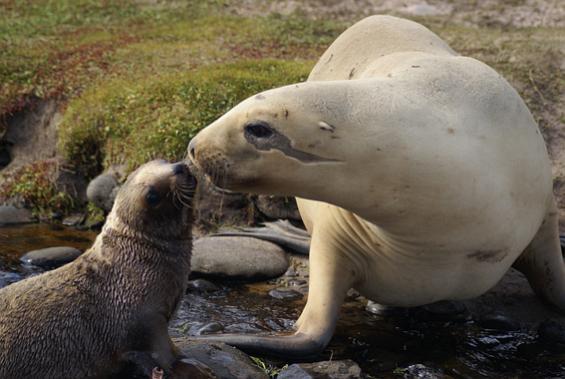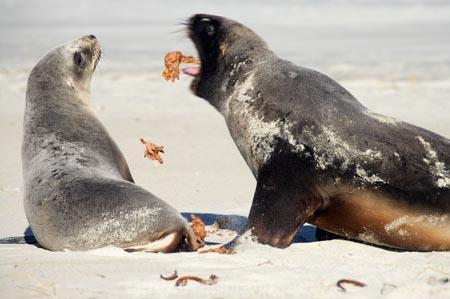The first image is the image on the left, the second image is the image on the right. Considering the images on both sides, is "There are four sea lions in the image pair." valid? Answer yes or no. Yes. The first image is the image on the left, the second image is the image on the right. Evaluate the accuracy of this statement regarding the images: "The right image contains exactly two seals.". Is it true? Answer yes or no. Yes. 